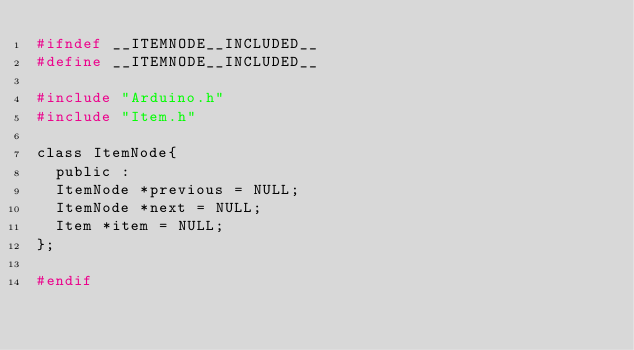<code> <loc_0><loc_0><loc_500><loc_500><_C_>#ifndef __ITEMNODE__INCLUDED__
#define __ITEMNODE__INCLUDED__

#include "Arduino.h"
#include "Item.h"

class ItemNode{
  public : 
  ItemNode *previous = NULL;
  ItemNode *next = NULL;
  Item *item = NULL;
};

#endif
</code> 